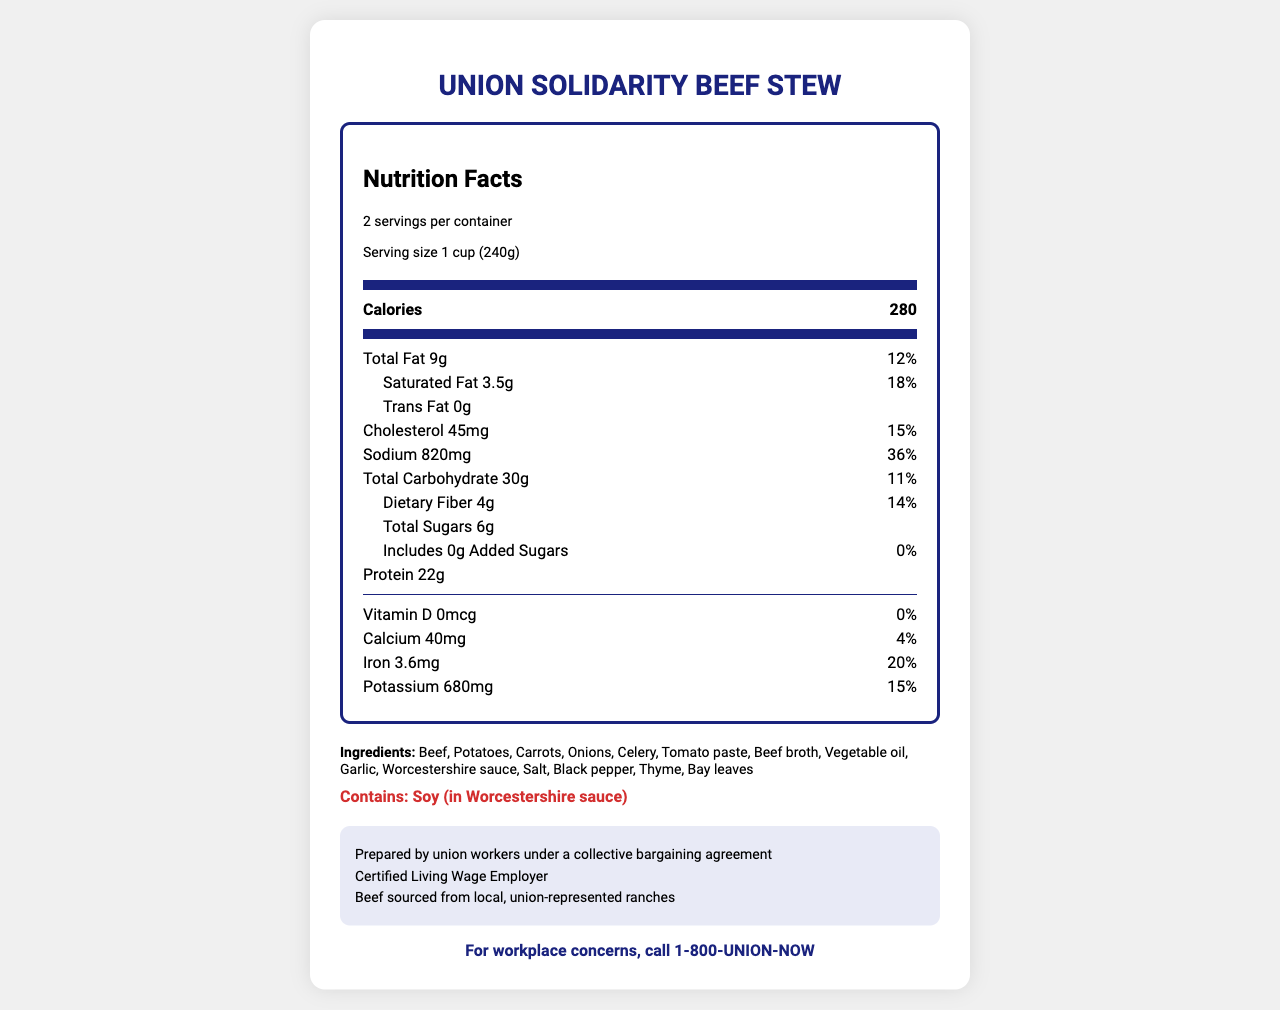what is the serving size of Union Solidarity Beef Stew? The serving size is explicitly mentioned as "1 cup (240g)" in the nutrition label.
Answer: 1 cup (240g) how many calories are there per serving? The calories per serving are listed as 280 on the nutrition label.
Answer: 280 how much protein does one serving of the stew provide? The amount of protein per serving is indicated as 22g on the nutrition label.
Answer: 22g list three ingredients in Union Solidarity Beef Stew. These ingredients are part of the list which includes "Beef, Potatoes, Carrots, Onions, Celery, Tomato paste..." and so forth.
Answer: Beef, Potatoes, Carrots what percentage of the daily value of sodium does one serving contain? The sodium daily value percentage is shown as 36% on the nutrition label.
Answer: 36% does the stew contain any trans fat? The trans fat content is listed as 0g, indicating the stew contains no trans fat.
Answer: No what kind of sustainability information is provided about the stew? A. Beef sourced from organic farms B. Beef sourced from local, union-represented ranches C. Beef sourced from international suppliers The sustainability info states "Beef sourced from local, union-represented ranches," making option B the correct answer.
Answer: B how many servings per container are there in Union Solidarity Beef Stew? A. 1 B. 2 C. 3 D. 4 The nutrition facts indicate there are 2 servings per container, so option B is correct.
Answer: B is there any Vitamin D in a serving of the stew? The amount of Vitamin D is listed as 0mcg, which corresponds to 0% of the daily value, indicating no Vitamin D is present.
Answer: No summarize the key details provided in the nutrition label of Union Solidarity Beef Stew. This summary encapsulates the main points of the nutrition facts, ingredients, and additional information provided in the document.
Answer: The Union Solidarity Beef Stew contains 280 calories per serving, with 2 servings per container. It provides 22g of protein, 9g of total fat, and 30g of carbohydrates. It has notable amounts of iron (20% DV) and potassium (15% DV) and 820mg of sodium (36% DV). Ingredients include beef, potatoes, and various vegetables. The product is prepared by union workers under a collective bargaining agreement, is a certified Living Wage Employer, and sources its beef from local, union-represented ranches. who is the contact for workplace concerns related to the stew production? The document lists "For workplace concerns, call 1-800-UNION-NOW."
Answer: 1-800-UNION-NOW how many grams of added sugars are in one serving? The nutrition label states that there are 0g of added sugars per serving.
Answer: 0g does the stew contain soy? The allergen information clearly mentions "Contains: Soy (in Worcestershire sauce)," indicating the presence of soy.
Answer: Yes what is the total carbohydrate content for one serving of the stew? The total carbohydrate amount per serving is listed as 30g in the nutrition label.
Answer: 30g how much iron does one serving of Union Solidarity Beef Stew contribute to the daily value percentage? The nutrition facts show that one serving provides 20% of the daily value for iron.
Answer: 20% what is the specific source of the beef used in this product? The document mentions that the beef is sourced from local, union-represented ranches, but it does not provide the specific supplier or location.
Answer: Not enough information what is the calories content for the entire container of the stew? Given that one serving contains 280 calories and there are 2 servings per container, the total calorie content for the entire container is 560 (280 x 2).
Answer: 560 